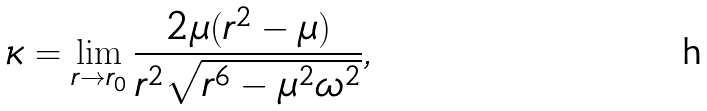<formula> <loc_0><loc_0><loc_500><loc_500>\kappa = \lim _ { r \to r _ { 0 } } \frac { 2 \mu ( r ^ { 2 } - \mu ) } { r ^ { 2 } \sqrt { r ^ { 6 } - \mu ^ { 2 } \omega ^ { 2 } } } ,</formula> 